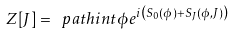<formula> <loc_0><loc_0><loc_500><loc_500>Z [ J ] = \ p a t h i n t { \phi } e ^ { i \left ( S _ { 0 } ( \phi ) + S _ { J } ( \phi , J ) \right ) }</formula> 